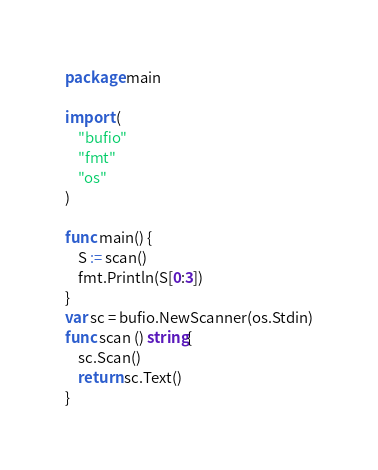Convert code to text. <code><loc_0><loc_0><loc_500><loc_500><_Go_>package main

import (
	"bufio"
	"fmt"
	"os"
)

func main() {
	S := scan()
	fmt.Println(S[0:3])
}
var sc = bufio.NewScanner(os.Stdin)
func scan () string{
	sc.Scan()
	return sc.Text()
}
</code> 